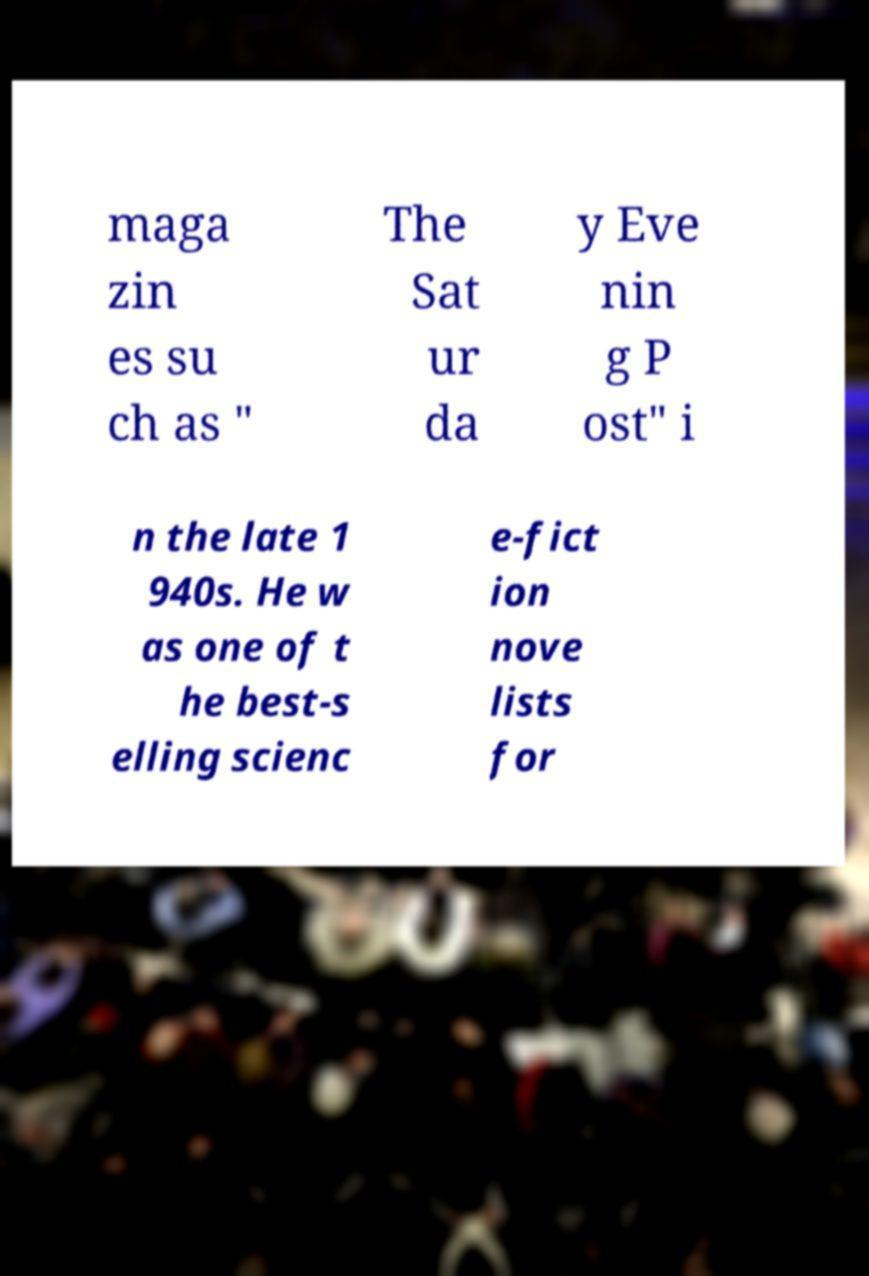What messages or text are displayed in this image? I need them in a readable, typed format. maga zin es su ch as " The Sat ur da y Eve nin g P ost" i n the late 1 940s. He w as one of t he best-s elling scienc e-fict ion nove lists for 